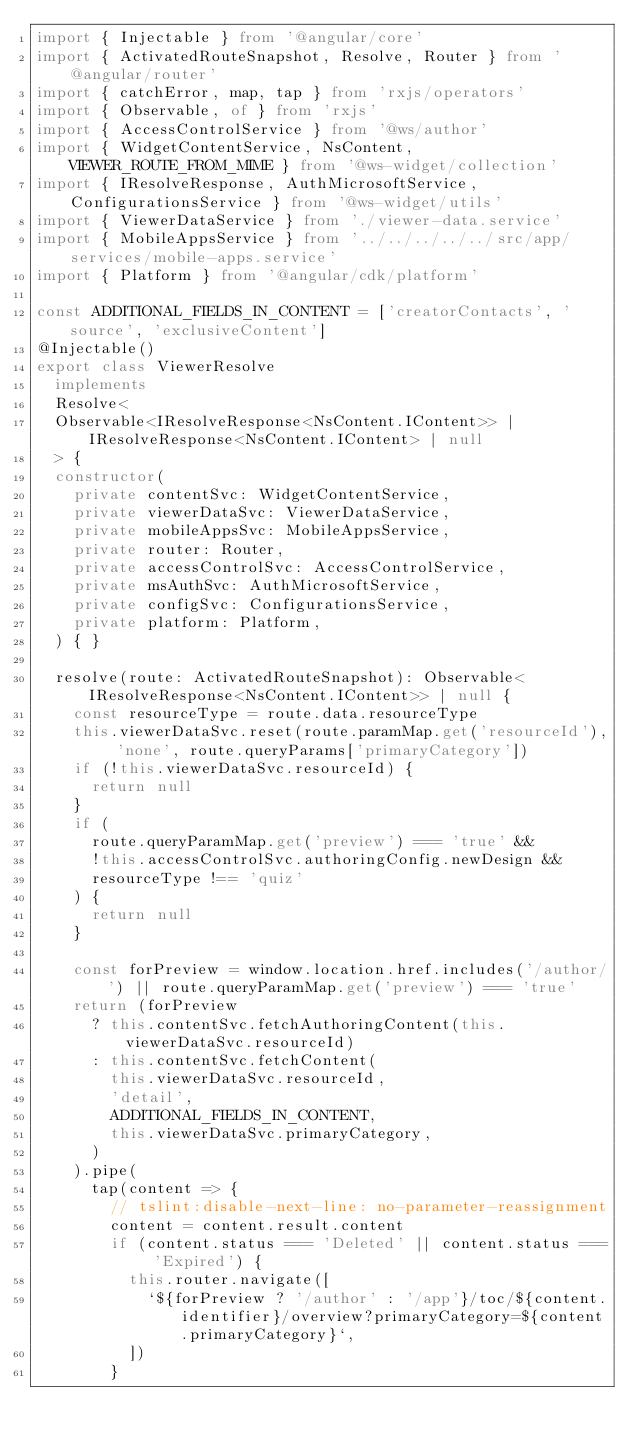Convert code to text. <code><loc_0><loc_0><loc_500><loc_500><_TypeScript_>import { Injectable } from '@angular/core'
import { ActivatedRouteSnapshot, Resolve, Router } from '@angular/router'
import { catchError, map, tap } from 'rxjs/operators'
import { Observable, of } from 'rxjs'
import { AccessControlService } from '@ws/author'
import { WidgetContentService, NsContent, VIEWER_ROUTE_FROM_MIME } from '@ws-widget/collection'
import { IResolveResponse, AuthMicrosoftService, ConfigurationsService } from '@ws-widget/utils'
import { ViewerDataService } from './viewer-data.service'
import { MobileAppsService } from '../../../../../src/app/services/mobile-apps.service'
import { Platform } from '@angular/cdk/platform'

const ADDITIONAL_FIELDS_IN_CONTENT = ['creatorContacts', 'source', 'exclusiveContent']
@Injectable()
export class ViewerResolve
  implements
  Resolve<
  Observable<IResolveResponse<NsContent.IContent>> | IResolveResponse<NsContent.IContent> | null
  > {
  constructor(
    private contentSvc: WidgetContentService,
    private viewerDataSvc: ViewerDataService,
    private mobileAppsSvc: MobileAppsService,
    private router: Router,
    private accessControlSvc: AccessControlService,
    private msAuthSvc: AuthMicrosoftService,
    private configSvc: ConfigurationsService,
    private platform: Platform,
  ) { }

  resolve(route: ActivatedRouteSnapshot): Observable<IResolveResponse<NsContent.IContent>> | null {
    const resourceType = route.data.resourceType
    this.viewerDataSvc.reset(route.paramMap.get('resourceId'), 'none', route.queryParams['primaryCategory'])
    if (!this.viewerDataSvc.resourceId) {
      return null
    }
    if (
      route.queryParamMap.get('preview') === 'true' &&
      !this.accessControlSvc.authoringConfig.newDesign &&
      resourceType !== 'quiz'
    ) {
      return null
    }

    const forPreview = window.location.href.includes('/author/') || route.queryParamMap.get('preview') === 'true'
    return (forPreview
      ? this.contentSvc.fetchAuthoringContent(this.viewerDataSvc.resourceId)
      : this.contentSvc.fetchContent(
        this.viewerDataSvc.resourceId,
        'detail',
        ADDITIONAL_FIELDS_IN_CONTENT,
        this.viewerDataSvc.primaryCategory,
      )
    ).pipe(
      tap(content => {
        // tslint:disable-next-line: no-parameter-reassignment
        content = content.result.content
        if (content.status === 'Deleted' || content.status === 'Expired') {
          this.router.navigate([
            `${forPreview ? '/author' : '/app'}/toc/${content.identifier}/overview?primaryCategory=${content.primaryCategory}`,
          ])
        }</code> 